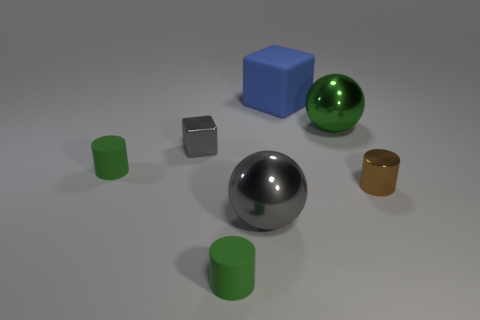What is the small gray block made of?
Provide a succinct answer. Metal. There is a block that is on the right side of the small gray metal object; what color is it?
Provide a short and direct response. Blue. How many small things are either gray rubber blocks or balls?
Give a very brief answer. 0. Is the color of the large metallic ball behind the small brown cylinder the same as the rubber thing behind the gray cube?
Your answer should be compact. No. How many other things are there of the same color as the large matte thing?
Ensure brevity in your answer.  0. What number of gray things are metal spheres or small metal cylinders?
Your response must be concise. 1. There is a brown object; does it have the same shape as the large gray metallic object in front of the tiny cube?
Provide a short and direct response. No. There is a small gray thing; what shape is it?
Keep it short and to the point. Cube. There is a brown cylinder that is the same size as the metal cube; what is its material?
Offer a very short reply. Metal. Is there any other thing that has the same size as the shiny cube?
Give a very brief answer. Yes. 